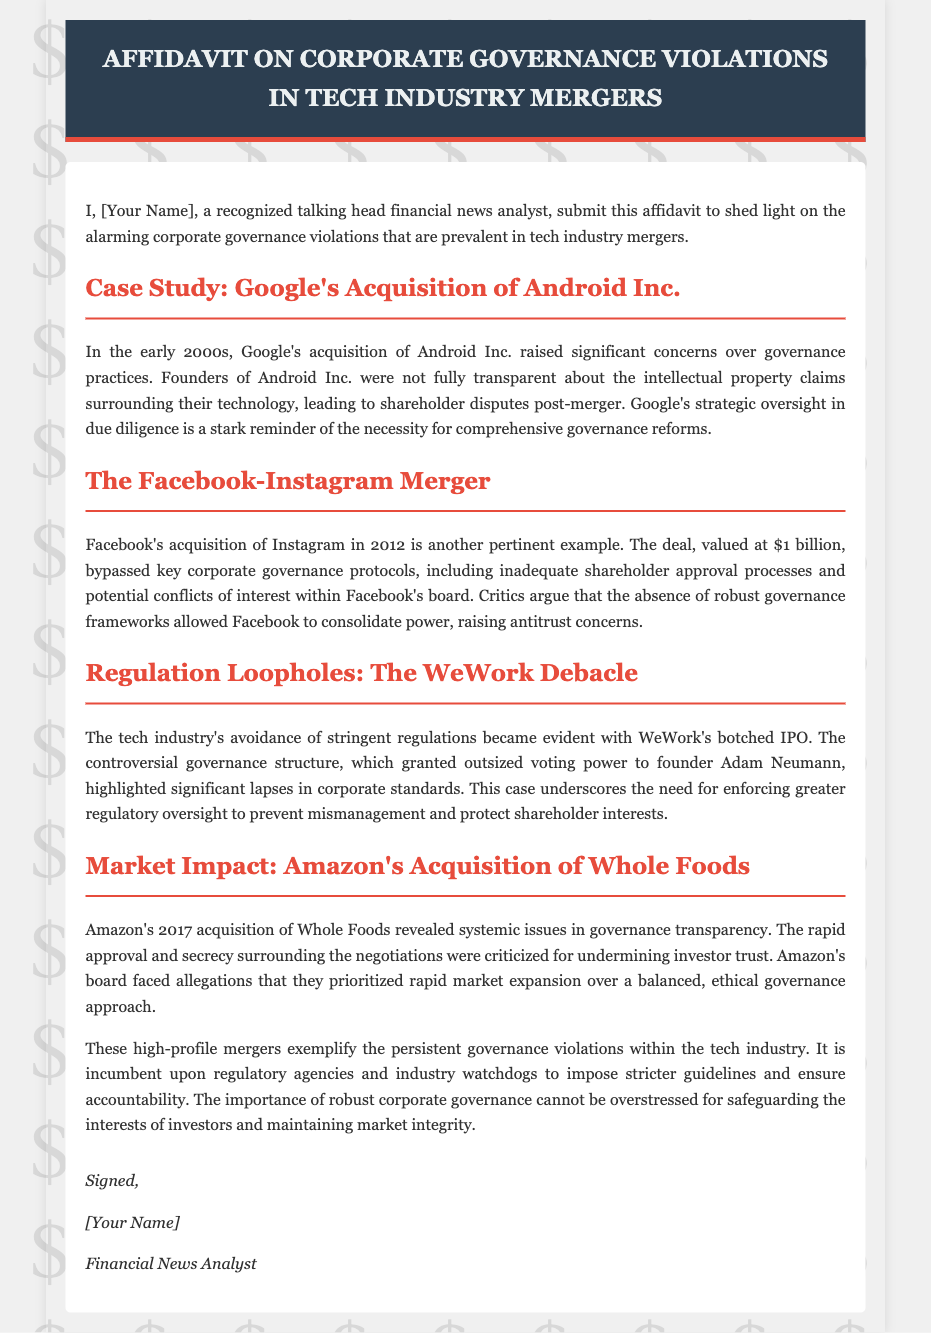What is the title of the affidavit? The title of the affidavit is explicitly indicated at the top of the document.
Answer: Affidavit on Corporate Governance Violations in Tech Industry Mergers Who was involved in Google's acquisition discussed in the document? The document specifically mentions the entity involved in the acquisition of Android Inc.
Answer: Google What significant issue arose from the Facebook-Instagram merger? The text highlights a key governance issue regarding approvals in corporate processes during this merger.
Answer: Inadequate shareholder approval processes What year did Facebook acquire Instagram? The document explicitly states the year the acquisition took place.
Answer: 2012 Which company's governance structure is highlighted as controversial related to WeWork? The affidavit mentions the founder of a specific company whose governance structure caused concern.
Answer: Adam Neumann What was the value of the Facebook-Instagram merger? The document provides the valuation of the deal made during the acquisition.
Answer: $1 billion Which acquisition raised concerns regarding governance transparency in 2017? The document names a company that faced issues related to governance transparency during its acquisition.
Answer: Amazon's Acquisition of Whole Foods What does the document emphasize as necessary for preventing mismanagement? The affidavit discusses the importance of a specific type of oversight emphasized for corporate governance.
Answer: Greater regulatory oversight What is the overarching theme of the affidavit? The document aims to shed light on a specific troubling aspect of mergers in the tech industry.
Answer: Corporate governance violations 